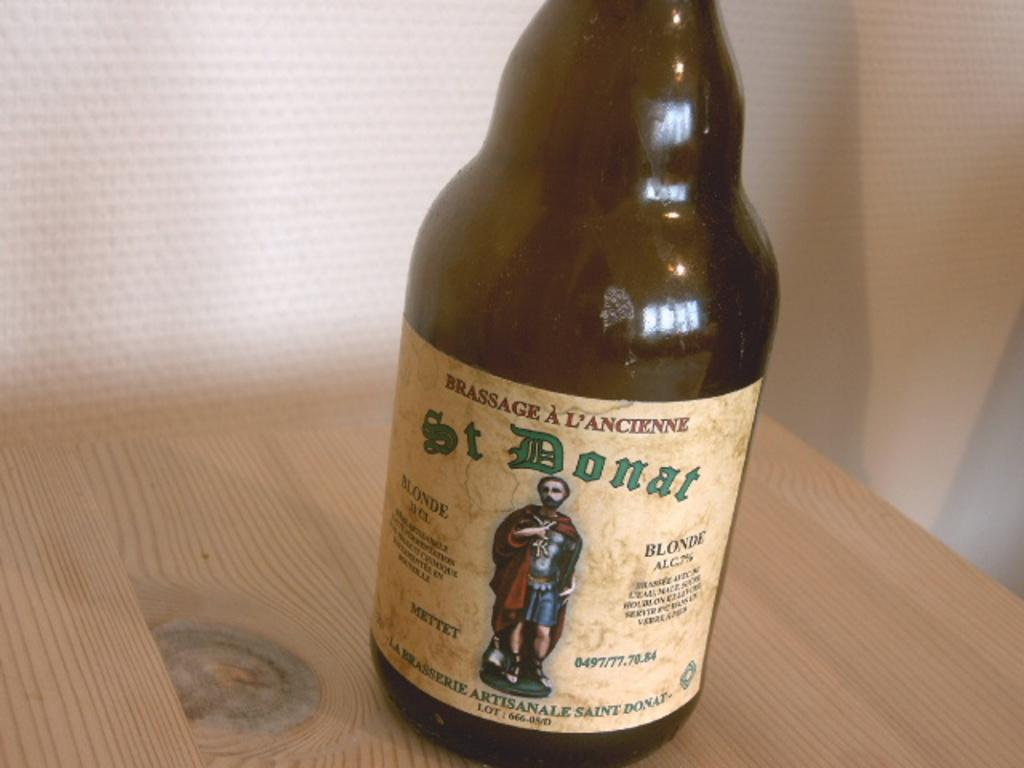<image>
Provide a brief description of the given image. A bottle of St. Donat wth a man from the Roman time on the label. 